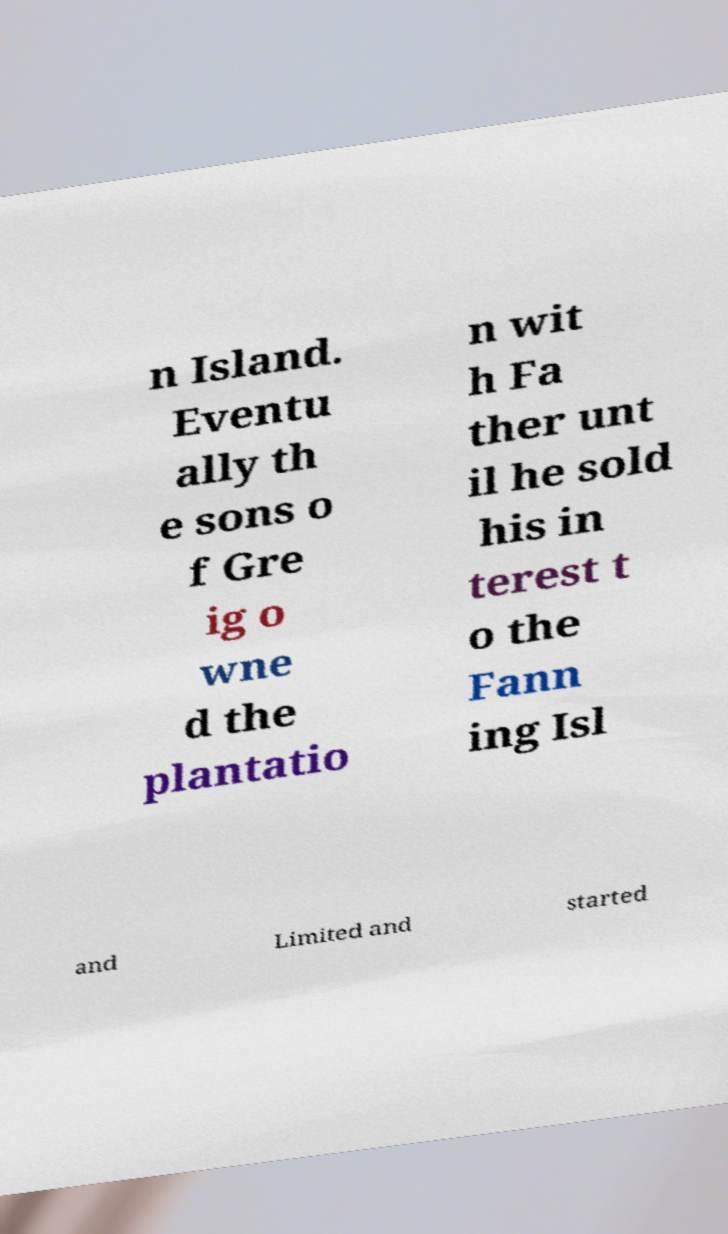There's text embedded in this image that I need extracted. Can you transcribe it verbatim? n Island. Eventu ally th e sons o f Gre ig o wne d the plantatio n wit h Fa ther unt il he sold his in terest t o the Fann ing Isl and Limited and started 